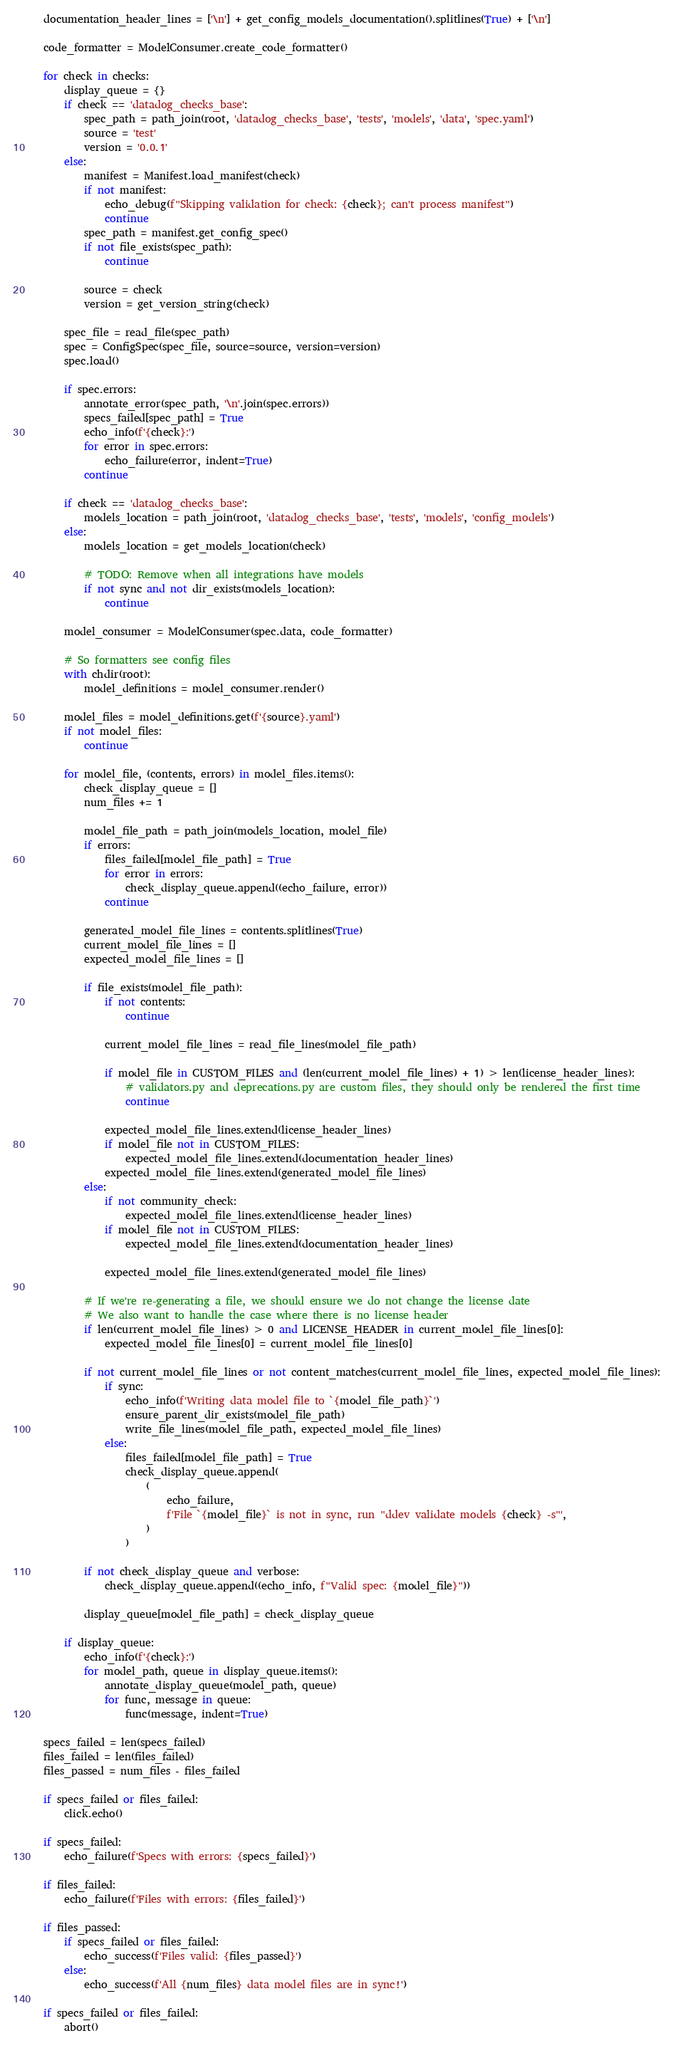<code> <loc_0><loc_0><loc_500><loc_500><_Python_>    documentation_header_lines = ['\n'] + get_config_models_documentation().splitlines(True) + ['\n']

    code_formatter = ModelConsumer.create_code_formatter()

    for check in checks:
        display_queue = {}
        if check == 'datadog_checks_base':
            spec_path = path_join(root, 'datadog_checks_base', 'tests', 'models', 'data', 'spec.yaml')
            source = 'test'
            version = '0.0.1'
        else:
            manifest = Manifest.load_manifest(check)
            if not manifest:
                echo_debug(f"Skipping validation for check: {check}; can't process manifest")
                continue
            spec_path = manifest.get_config_spec()
            if not file_exists(spec_path):
                continue

            source = check
            version = get_version_string(check)

        spec_file = read_file(spec_path)
        spec = ConfigSpec(spec_file, source=source, version=version)
        spec.load()

        if spec.errors:
            annotate_error(spec_path, '\n'.join(spec.errors))
            specs_failed[spec_path] = True
            echo_info(f'{check}:')
            for error in spec.errors:
                echo_failure(error, indent=True)
            continue

        if check == 'datadog_checks_base':
            models_location = path_join(root, 'datadog_checks_base', 'tests', 'models', 'config_models')
        else:
            models_location = get_models_location(check)

            # TODO: Remove when all integrations have models
            if not sync and not dir_exists(models_location):
                continue

        model_consumer = ModelConsumer(spec.data, code_formatter)

        # So formatters see config files
        with chdir(root):
            model_definitions = model_consumer.render()

        model_files = model_definitions.get(f'{source}.yaml')
        if not model_files:
            continue

        for model_file, (contents, errors) in model_files.items():
            check_display_queue = []
            num_files += 1

            model_file_path = path_join(models_location, model_file)
            if errors:
                files_failed[model_file_path] = True
                for error in errors:
                    check_display_queue.append((echo_failure, error))
                continue

            generated_model_file_lines = contents.splitlines(True)
            current_model_file_lines = []
            expected_model_file_lines = []

            if file_exists(model_file_path):
                if not contents:
                    continue

                current_model_file_lines = read_file_lines(model_file_path)

                if model_file in CUSTOM_FILES and (len(current_model_file_lines) + 1) > len(license_header_lines):
                    # validators.py and deprecations.py are custom files, they should only be rendered the first time
                    continue

                expected_model_file_lines.extend(license_header_lines)
                if model_file not in CUSTOM_FILES:
                    expected_model_file_lines.extend(documentation_header_lines)
                expected_model_file_lines.extend(generated_model_file_lines)
            else:
                if not community_check:
                    expected_model_file_lines.extend(license_header_lines)
                if model_file not in CUSTOM_FILES:
                    expected_model_file_lines.extend(documentation_header_lines)

                expected_model_file_lines.extend(generated_model_file_lines)

            # If we're re-generating a file, we should ensure we do not change the license date
            # We also want to handle the case where there is no license header
            if len(current_model_file_lines) > 0 and LICENSE_HEADER in current_model_file_lines[0]:
                expected_model_file_lines[0] = current_model_file_lines[0]

            if not current_model_file_lines or not content_matches(current_model_file_lines, expected_model_file_lines):
                if sync:
                    echo_info(f'Writing data model file to `{model_file_path}`')
                    ensure_parent_dir_exists(model_file_path)
                    write_file_lines(model_file_path, expected_model_file_lines)
                else:
                    files_failed[model_file_path] = True
                    check_display_queue.append(
                        (
                            echo_failure,
                            f'File `{model_file}` is not in sync, run "ddev validate models {check} -s"',
                        )
                    )

            if not check_display_queue and verbose:
                check_display_queue.append((echo_info, f"Valid spec: {model_file}"))

            display_queue[model_file_path] = check_display_queue

        if display_queue:
            echo_info(f'{check}:')
            for model_path, queue in display_queue.items():
                annotate_display_queue(model_path, queue)
                for func, message in queue:
                    func(message, indent=True)

    specs_failed = len(specs_failed)
    files_failed = len(files_failed)
    files_passed = num_files - files_failed

    if specs_failed or files_failed:
        click.echo()

    if specs_failed:
        echo_failure(f'Specs with errors: {specs_failed}')

    if files_failed:
        echo_failure(f'Files with errors: {files_failed}')

    if files_passed:
        if specs_failed or files_failed:
            echo_success(f'Files valid: {files_passed}')
        else:
            echo_success(f'All {num_files} data model files are in sync!')

    if specs_failed or files_failed:
        abort()
</code> 